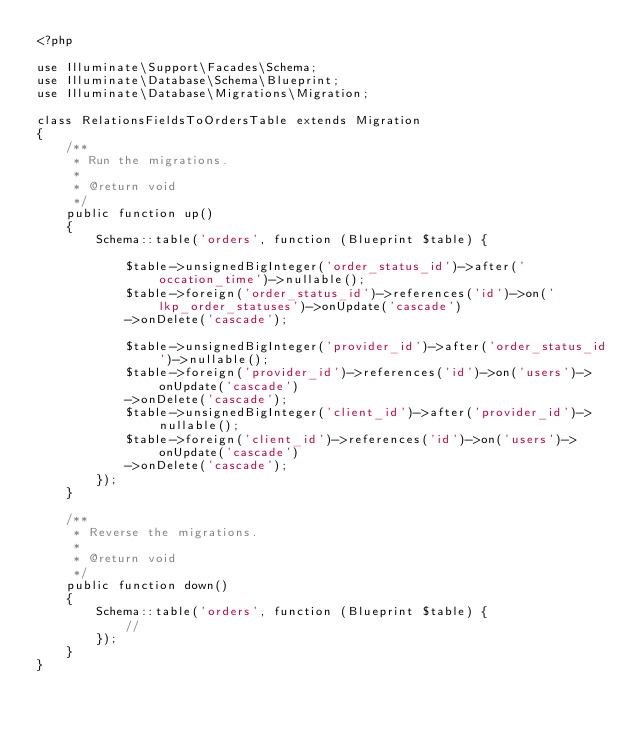Convert code to text. <code><loc_0><loc_0><loc_500><loc_500><_PHP_><?php

use Illuminate\Support\Facades\Schema;
use Illuminate\Database\Schema\Blueprint;
use Illuminate\Database\Migrations\Migration;

class RelationsFieldsToOrdersTable extends Migration
{
    /**
     * Run the migrations.
     *
     * @return void
     */
    public function up()
    {
        Schema::table('orders', function (Blueprint $table) {

            $table->unsignedBigInteger('order_status_id')->after('occation_time')->nullable();
            $table->foreign('order_status_id')->references('id')->on('lkp_order_statuses')->onUpdate('cascade')
            ->onDelete('cascade');

            $table->unsignedBigInteger('provider_id')->after('order_status_id')->nullable();
            $table->foreign('provider_id')->references('id')->on('users')->onUpdate('cascade')
            ->onDelete('cascade');
            $table->unsignedBigInteger('client_id')->after('provider_id')->nullable();
            $table->foreign('client_id')->references('id')->on('users')->onUpdate('cascade')
            ->onDelete('cascade');
        });
    }

    /**
     * Reverse the migrations.
     *
     * @return void
     */
    public function down()
    {
        Schema::table('orders', function (Blueprint $table) {
            //
        });
    }
}
</code> 